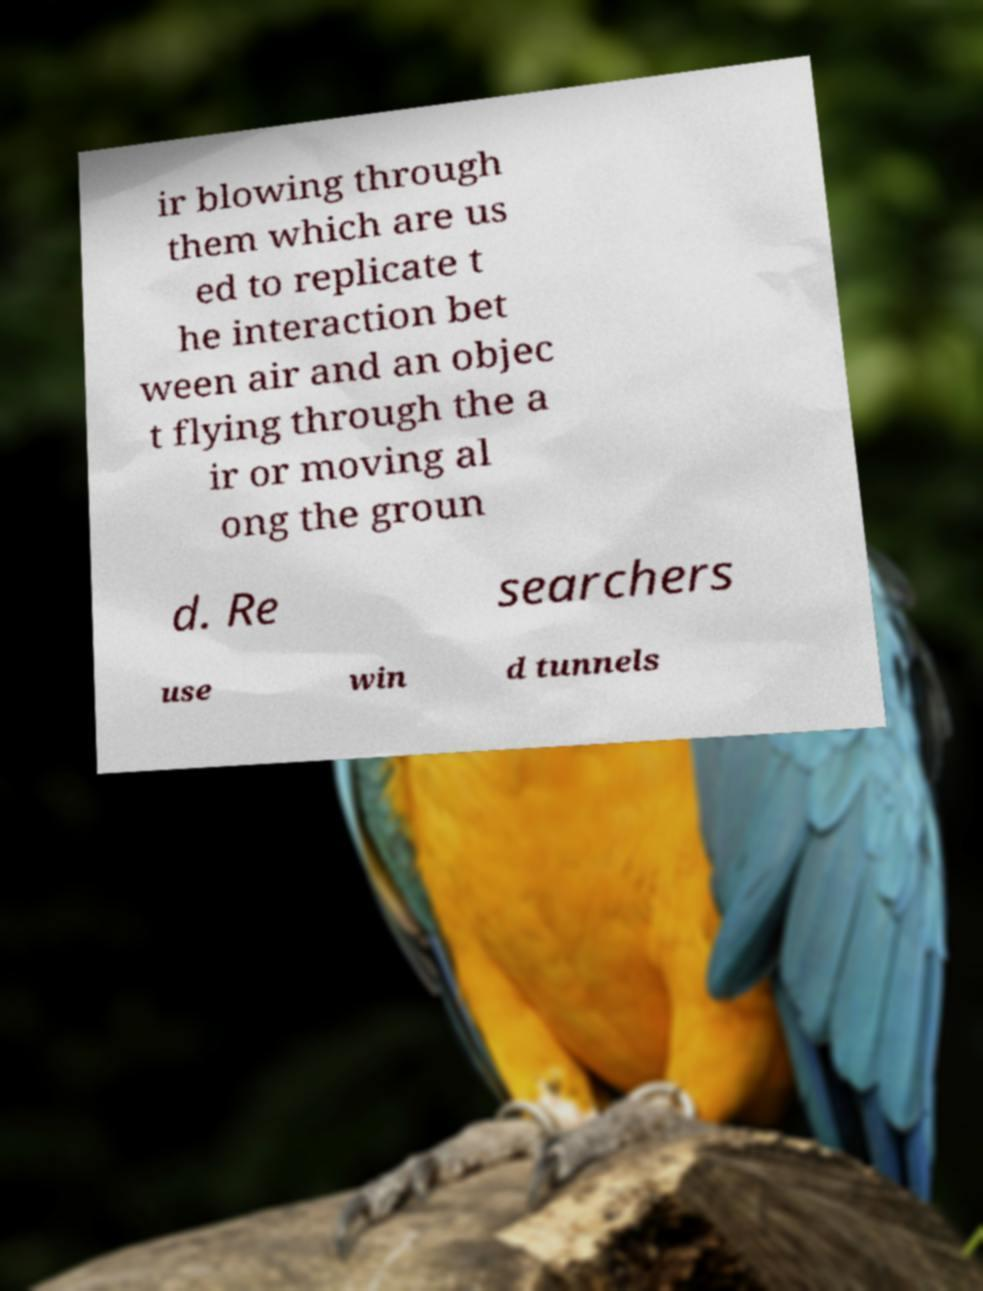What messages or text are displayed in this image? I need them in a readable, typed format. ir blowing through them which are us ed to replicate t he interaction bet ween air and an objec t flying through the a ir or moving al ong the groun d. Re searchers use win d tunnels 